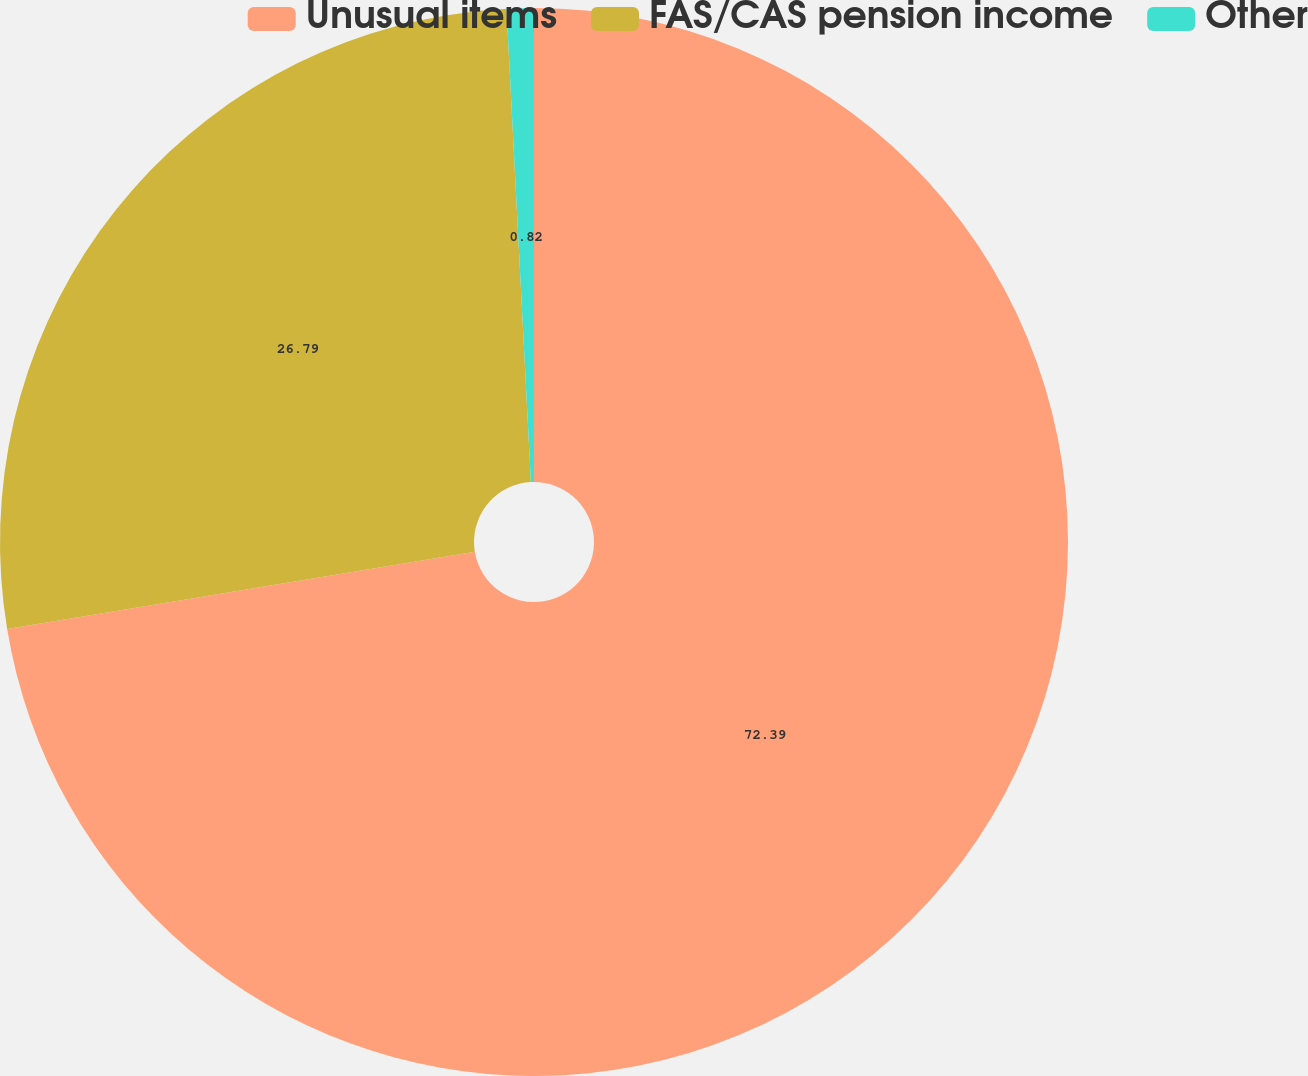Convert chart to OTSL. <chart><loc_0><loc_0><loc_500><loc_500><pie_chart><fcel>Unusual items<fcel>FAS/CAS pension income<fcel>Other<nl><fcel>72.4%<fcel>26.79%<fcel>0.82%<nl></chart> 